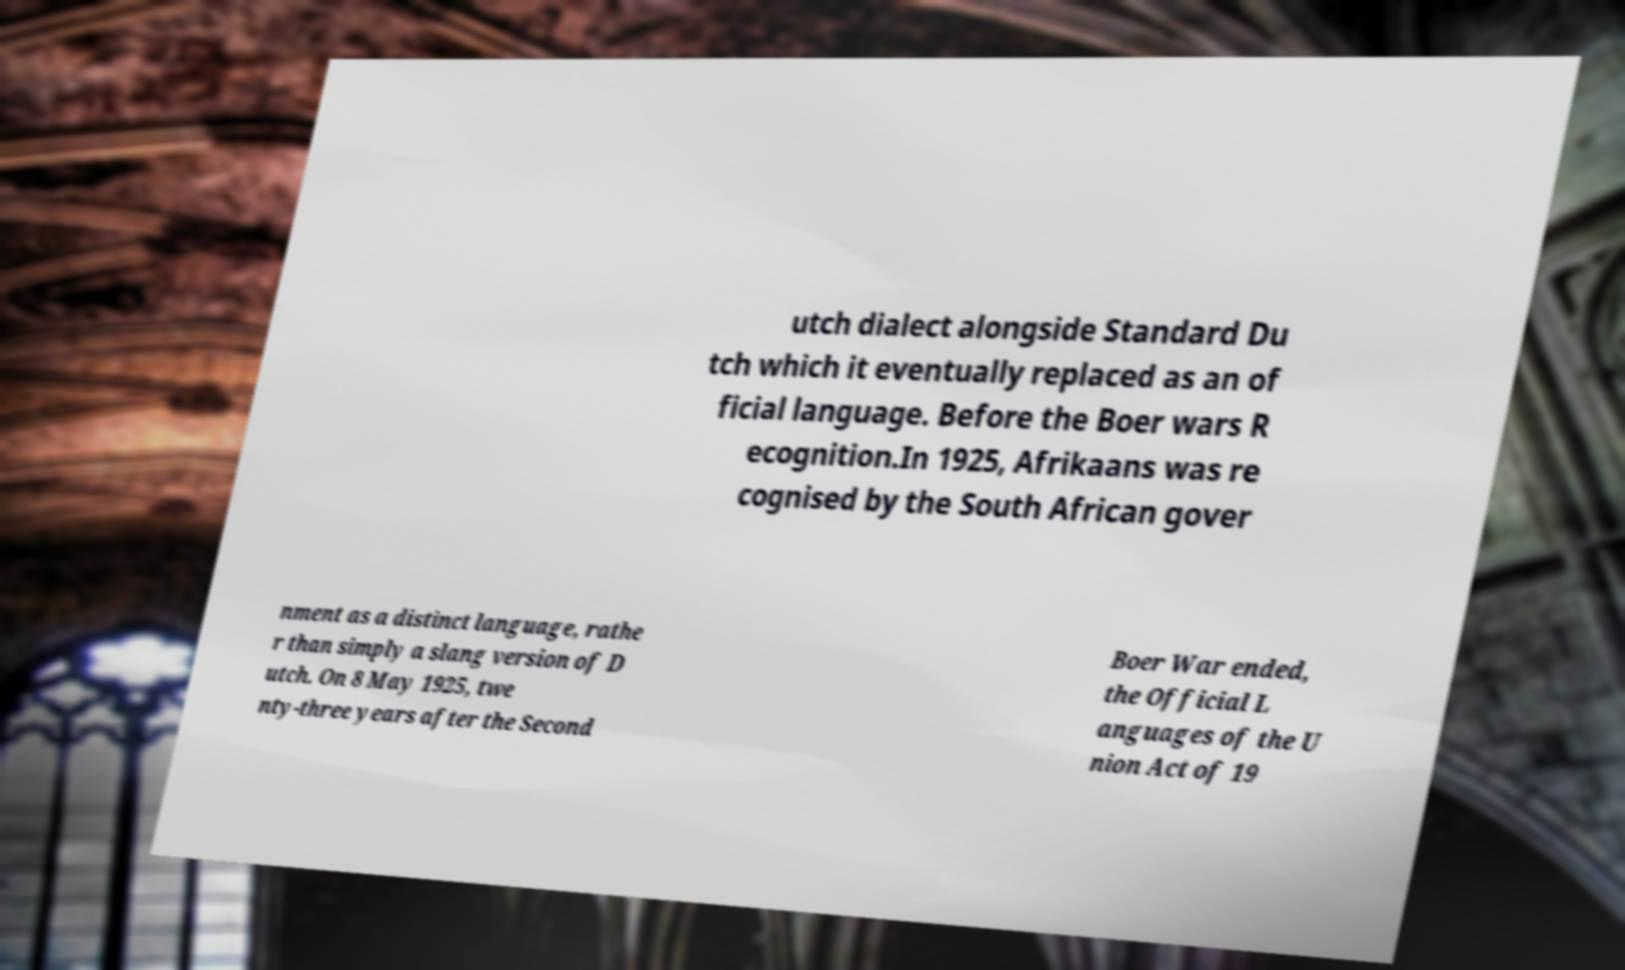Could you assist in decoding the text presented in this image and type it out clearly? utch dialect alongside Standard Du tch which it eventually replaced as an of ficial language. Before the Boer wars R ecognition.In 1925, Afrikaans was re cognised by the South African gover nment as a distinct language, rathe r than simply a slang version of D utch. On 8 May 1925, twe nty-three years after the Second Boer War ended, the Official L anguages of the U nion Act of 19 